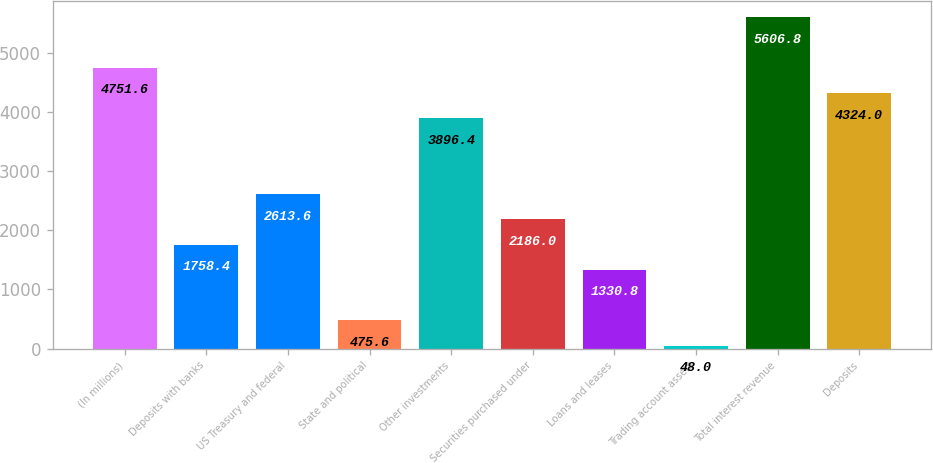<chart> <loc_0><loc_0><loc_500><loc_500><bar_chart><fcel>(In millions)<fcel>Deposits with banks<fcel>US Treasury and federal<fcel>State and political<fcel>Other investments<fcel>Securities purchased under<fcel>Loans and leases<fcel>Trading account assets<fcel>Total interest revenue<fcel>Deposits<nl><fcel>4751.6<fcel>1758.4<fcel>2613.6<fcel>475.6<fcel>3896.4<fcel>2186<fcel>1330.8<fcel>48<fcel>5606.8<fcel>4324<nl></chart> 